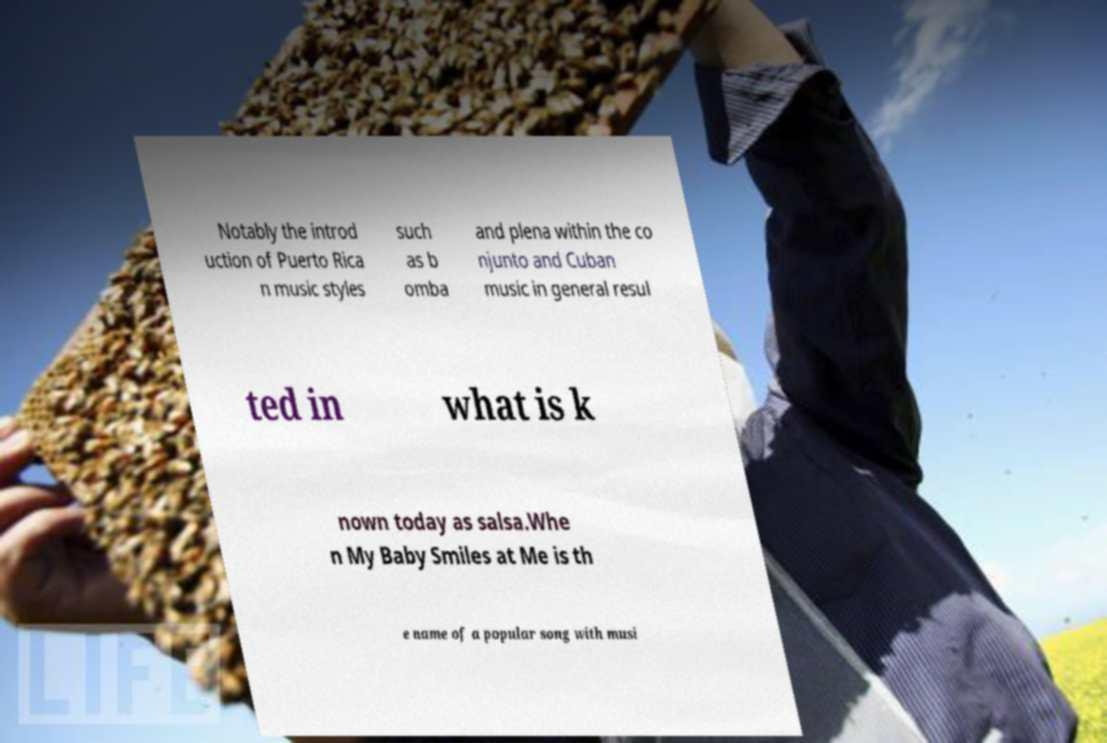Can you accurately transcribe the text from the provided image for me? Notably the introd uction of Puerto Rica n music styles such as b omba and plena within the co njunto and Cuban music in general resul ted in what is k nown today as salsa.Whe n My Baby Smiles at Me is th e name of a popular song with musi 